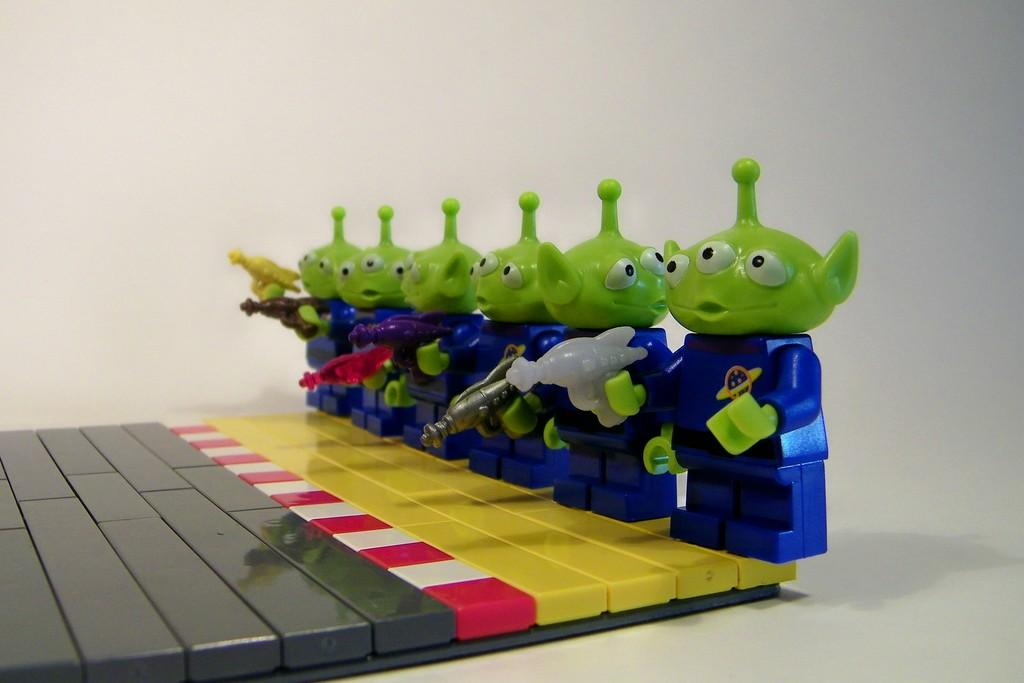How many plastic toys are visible in the image? There are six plastic toys in the image. What are the toys holding in their hands? The toys are holding guns in the image. What surface are the toys standing on? The toys are standing on a plastic board. What can be seen in the background of the image? There is a wall in the background of the image. What type of polish is being applied to the toys in the image? There is no polish being applied to the toys in the image; they are plastic toys holding guns. 